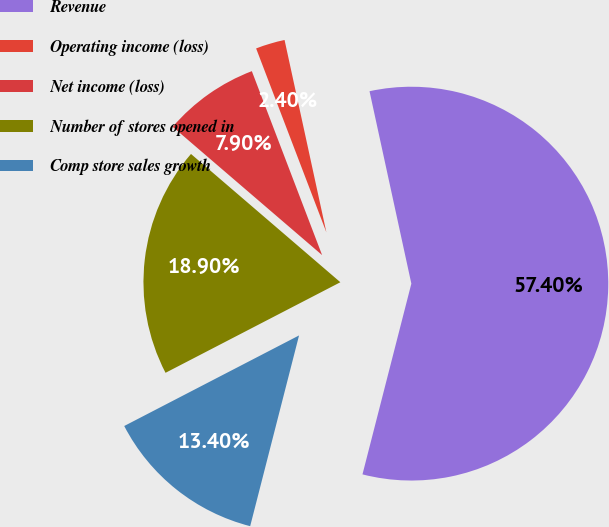<chart> <loc_0><loc_0><loc_500><loc_500><pie_chart><fcel>Revenue<fcel>Operating income (loss)<fcel>Net income (loss)<fcel>Number of stores opened in<fcel>Comp store sales growth<nl><fcel>57.4%<fcel>2.4%<fcel>7.9%<fcel>18.9%<fcel>13.4%<nl></chart> 